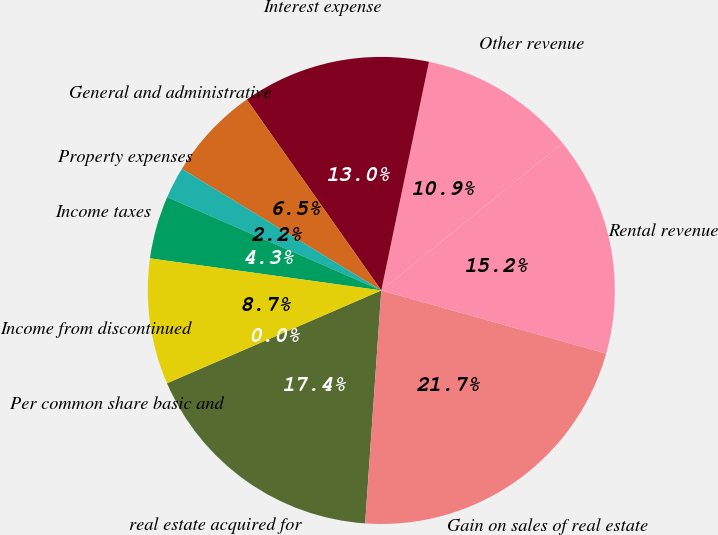<chart> <loc_0><loc_0><loc_500><loc_500><pie_chart><fcel>real estate acquired for<fcel>Gain on sales of real estate<fcel>Rental revenue<fcel>Other revenue<fcel>Interest expense<fcel>General and administrative<fcel>Property expenses<fcel>Income taxes<fcel>Income from discontinued<fcel>Per common share basic and<nl><fcel>17.39%<fcel>21.74%<fcel>15.22%<fcel>10.87%<fcel>13.04%<fcel>6.52%<fcel>2.17%<fcel>4.35%<fcel>8.7%<fcel>0.0%<nl></chart> 